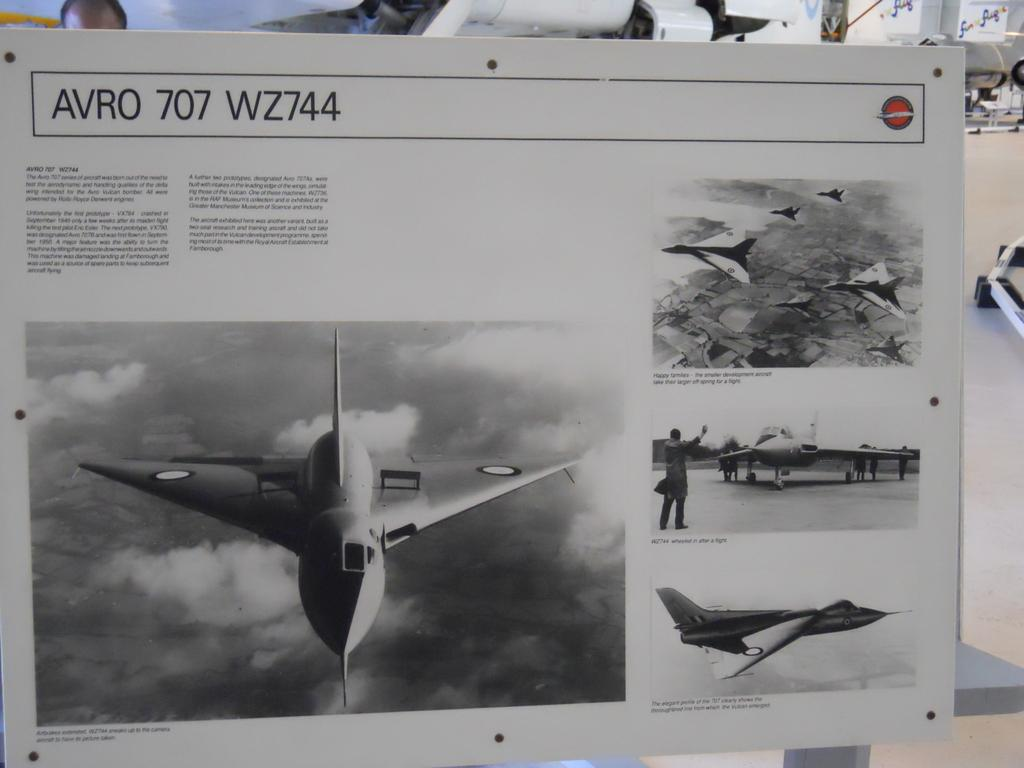What is the main subject of the board in the image? The main subject of the board in the image is pictures of fighter jets. What else is present on the board besides the pictures? There is text on the board. Can you describe the human head visible in the image? A human head is visible in the image, but no other details about the person are provided. What is the background of the board? The back of the board has pictures of planes. What piece of furniture is present in the image? There is a table in the image. How many boys are serving the person with the human head in the image? There is no boy or servant present in the image; it only features a board with pictures of fighter jets, text, and a human head. What type of hair can be seen on the person with the human head in the image? There is no hair visible on the person with the human head in the image, as only the head is shown. 